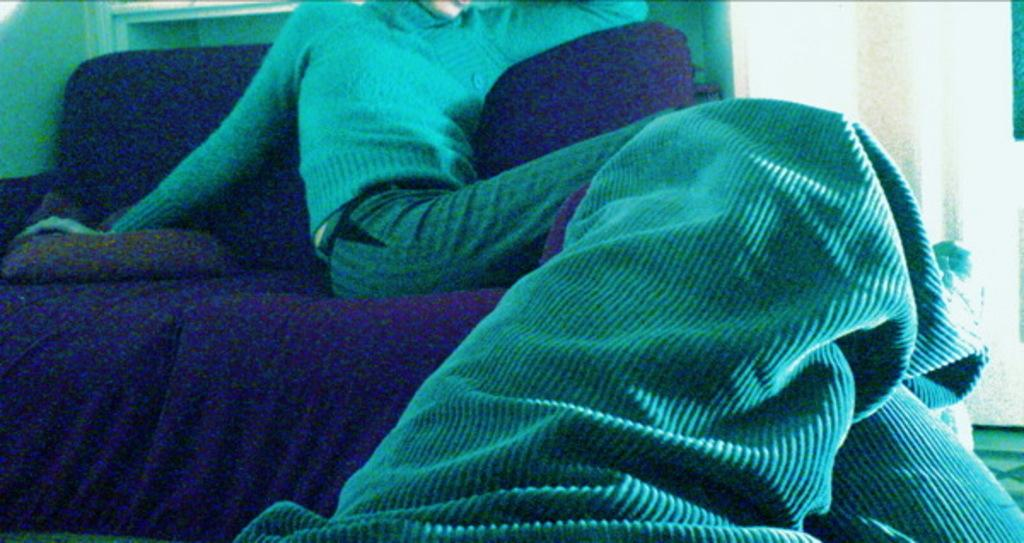What is the person in the image doing? There is a person sitting on a couch in the image. What is on the couch with the person? There are pillows on the couch. What can be seen at the bottom of the image? Clothes are visible at the bottom of the image. What is visible in the background of the image? There is a wall and objects in the background of the image. Where is the calendar located in the image? There is no calendar present in the image. What type of bomb is visible in the image? There is no bomb present in the image. 